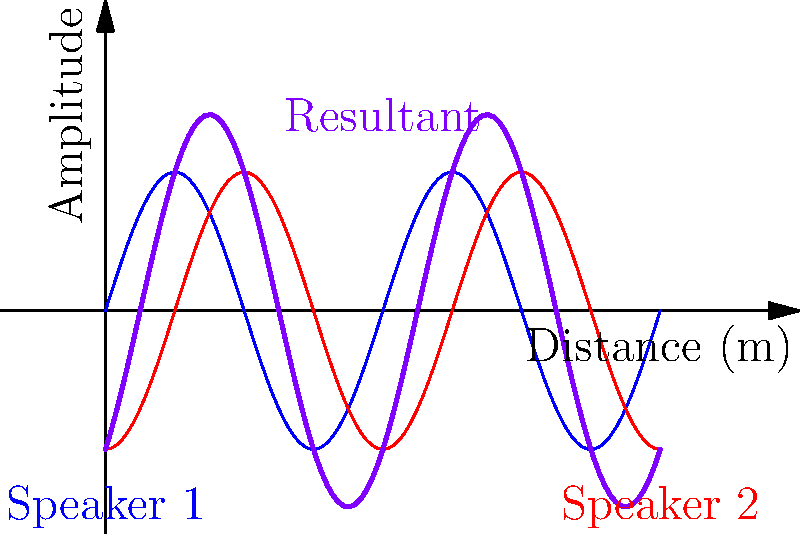In a concert venue, two speakers are placed 1 meter apart, both emitting a 340 Hz tone. The sound waves from these speakers interfere, creating the pattern shown in the graph. At which points along the x-axis (representing distance in meters) would a sound engineer find the loudest sound (constructive interference)? To solve this problem, we need to follow these steps:

1) First, recall that constructive interference occurs when waves are in phase, resulting in maximum amplitude.

2) The frequency of the sound is 340 Hz, and the speed of sound in air is approximately 340 m/s. We can calculate the wavelength:

   $\lambda = \frac{v}{f} = \frac{340 \text{ m/s}}{340 \text{ Hz}} = 1 \text{ m}$

3) The graph shows one complete cycle over 2 meters, confirming our wavelength calculation.

4) Constructive interference occurs when the path difference between the two waves is an integer multiple of the wavelength:

   $\Delta r = n\lambda$, where $n = 0, 1, 2, ...$

5) Given the speakers are 1 meter apart, the points of constructive interference will be where:

   $|r_1 - r_2| = n\lambda = n \text{ m}$

6) Looking at the graph, we can see that the maximum amplitudes (purple peaks) occur at x = 0 m, 1 m, and 2 m.

7) These correspond to:
   - At 0 m and 2 m: both waves travel the same distance (n = 0)
   - At 1 m: one wave travels 1 m further than the other (n = 1)

Therefore, the sound engineer would find the loudest sound at 0 m, 1 m, and 2 m along the x-axis.
Answer: 0 m, 1 m, and 2 m 